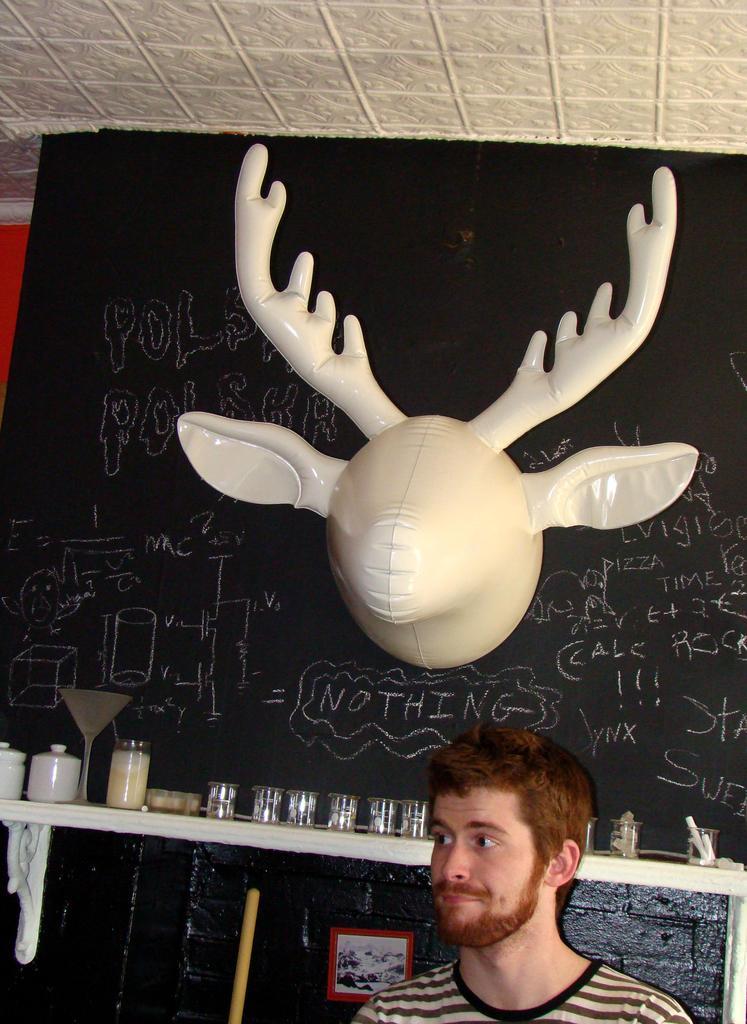In one or two sentences, can you explain what this image depicts? At the bottom, we see a man. Behind him, we see a table on which glasses, jars and the glass bottle is placed. Behind that, we see a board in black color with some text written on it. We even see a toy of reindeer is placed on that board. At the top, we see the ceiling of the room. 